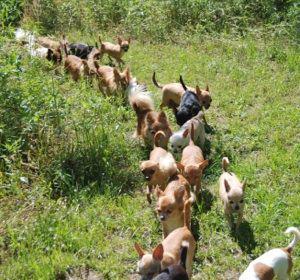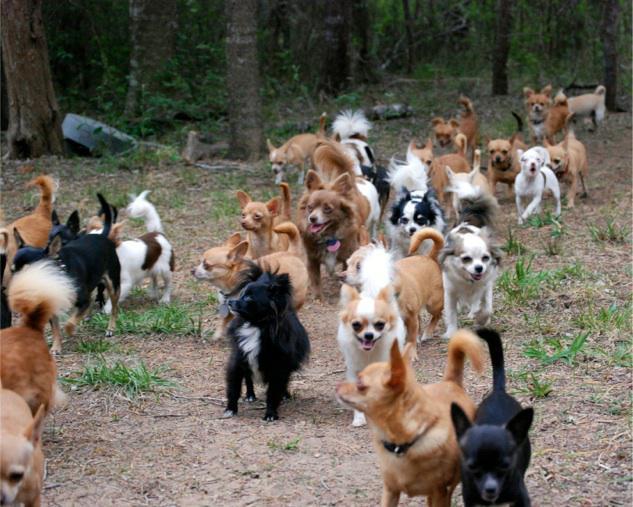The first image is the image on the left, the second image is the image on the right. Evaluate the accuracy of this statement regarding the images: "There are more than 10 dogs in the image on the left.". Is it true? Answer yes or no. Yes. 